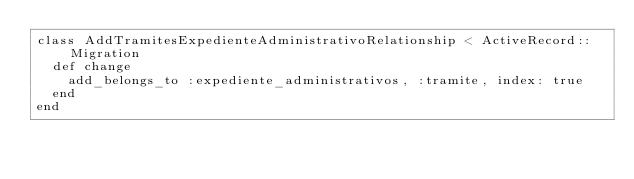Convert code to text. <code><loc_0><loc_0><loc_500><loc_500><_Ruby_>class AddTramitesExpedienteAdministrativoRelationship < ActiveRecord::Migration
  def change
    add_belongs_to :expediente_administrativos, :tramite, index: true
  end
end
</code> 